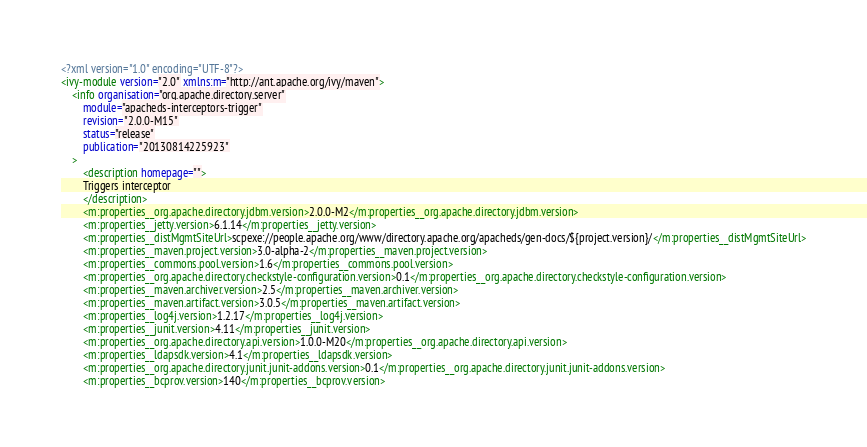<code> <loc_0><loc_0><loc_500><loc_500><_XML_><?xml version="1.0" encoding="UTF-8"?>
<ivy-module version="2.0" xmlns:m="http://ant.apache.org/ivy/maven">
	<info organisation="org.apache.directory.server"
		module="apacheds-interceptors-trigger"
		revision="2.0.0-M15"
		status="release"
		publication="20130814225923"
	>
		<description homepage="">
		Triggers interceptor
		</description>
		<m:properties__org.apache.directory.jdbm.version>2.0.0-M2</m:properties__org.apache.directory.jdbm.version>
		<m:properties__jetty.version>6.1.14</m:properties__jetty.version>
		<m:properties__distMgmtSiteUrl>scpexe://people.apache.org/www/directory.apache.org/apacheds/gen-docs/${project.version}/</m:properties__distMgmtSiteUrl>
		<m:properties__maven.project.version>3.0-alpha-2</m:properties__maven.project.version>
		<m:properties__commons.pool.version>1.6</m:properties__commons.pool.version>
		<m:properties__org.apache.directory.checkstyle-configuration.version>0.1</m:properties__org.apache.directory.checkstyle-configuration.version>
		<m:properties__maven.archiver.version>2.5</m:properties__maven.archiver.version>
		<m:properties__maven.artifact.version>3.0.5</m:properties__maven.artifact.version>
		<m:properties__log4j.version>1.2.17</m:properties__log4j.version>
		<m:properties__junit.version>4.11</m:properties__junit.version>
		<m:properties__org.apache.directory.api.version>1.0.0-M20</m:properties__org.apache.directory.api.version>
		<m:properties__ldapsdk.version>4.1</m:properties__ldapsdk.version>
		<m:properties__org.apache.directory.junit.junit-addons.version>0.1</m:properties__org.apache.directory.junit.junit-addons.version>
		<m:properties__bcprov.version>140</m:properties__bcprov.version></code> 